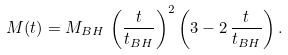<formula> <loc_0><loc_0><loc_500><loc_500>M ( t ) = M _ { B H } \, \left ( \frac { t } { t _ { B H } } \right ) ^ { 2 } \left ( 3 - 2 \, \frac { t } { t _ { B H } } \right ) .</formula> 